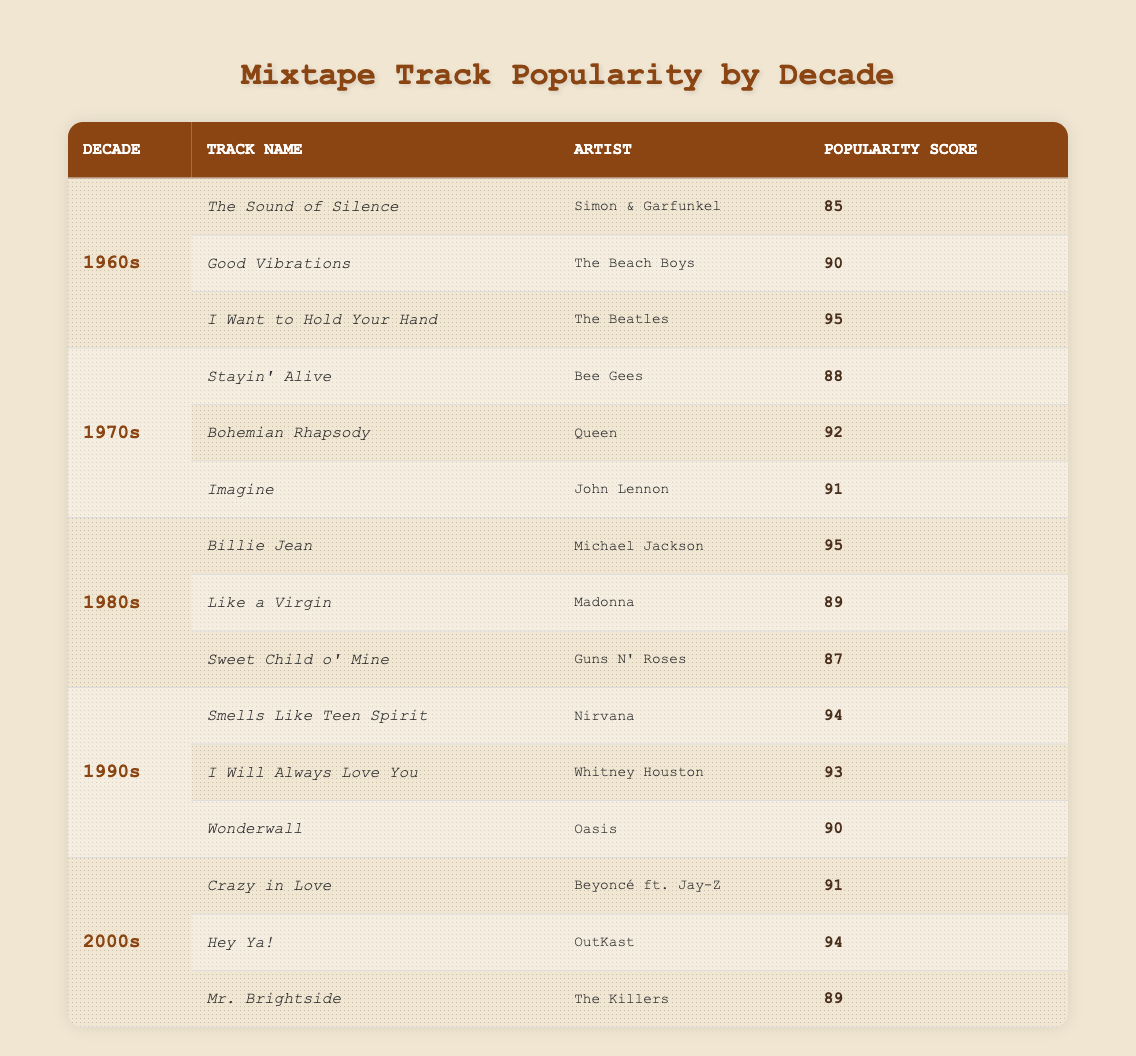What is the most popular track from the 1980s? The track "Billie Jean" by Michael Jackson has a popularity score of 95, which is the highest among all the tracks listed for the 1980s.
Answer: Billie Jean Which decade has the highest average popularity score? To find the average popularity score for each decade, we need to calculate the average for each set of top tracks. For the 1960s, the average is (85 + 90 + 95) / 3 = 90. For the 1970s, it's (88 + 92 + 91) / 3 = 90.33. The 1980s average is (95 + 89 + 87) / 3 = 90.33. For the 1990s, it's (94 + 93 + 90) / 3 = 92.33. And for the 2000s, it's (91 + 94 + 89) / 3 = 91.33. The highest average is for the 1990s at 92.33.
Answer: 1990s Is "I Want to Hold Your Hand" more popular than "Imagine"? "I Want to Hold Your Hand" has a popularity score of 95, while "Imagine" has 91. Since 95 is greater than 91, "I Want to Hold Your Hand" is more popular.
Answer: Yes Which artist has the highest rated track across all decades? We compare the popularity scores of all tracks. The highest score is for "Billie Jean" by Michael Jackson at 95. This is the only score in the table that reaches 95, which makes it the highest rated track across all decades.
Answer: Michael Jackson How do the total popularity scores of the 1990s and 2000s compare? We sum the popularity scores for the 1990s: 94 + 93 + 90 = 277. For the 2000s: 91 + 94 + 89 = 274. Comparing these sums, 277 for the 1990s is greater than 274 for the 2000s, indicating that the 1990s have a higher total popularity score.
Answer: 1990s have a higher total score What is the popularity score difference between the top track of the 1960s and the 1970s? The top track of the 1960s is "I Want to Hold Your Hand" with a popularity score of 95. The top track of the 1970s is "Bohemian Rhapsody" with a score of 92. The difference is 95 - 92 = 3.
Answer: 3 Is "Good Vibrations" the only track from the 1960s with a score above 88? The scores of the tracks from the 1960s are 85, 90, and 95. "Good Vibrations" has a score of 90, but there is also "I Want to Hold Your Hand" with a score of 95, which means that "Good Vibrations" is not the only track above 88.
Answer: No Which decade features a track by both Beyoncé and The Killers? Beyoncé is featured with "Crazy in Love" in the 2000s, while The Killers have "Mr. Brightside," also from the 2000s. Both artists are present in the same decade, thus it indicates that this decade features tracks by both artists.
Answer: 2000s 